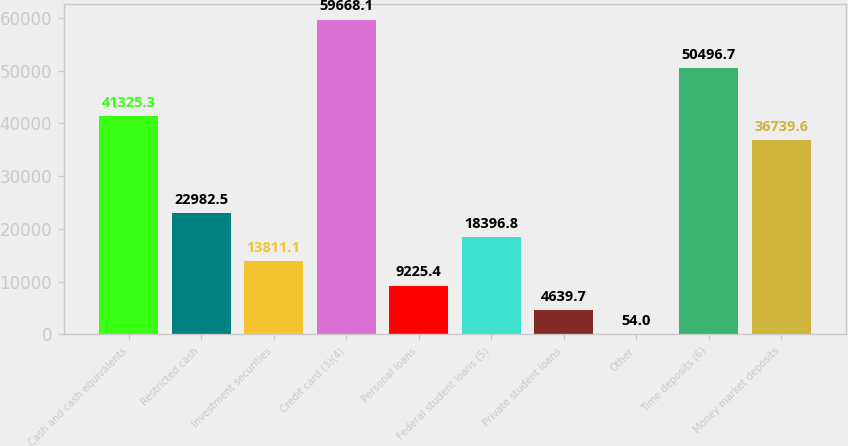Convert chart to OTSL. <chart><loc_0><loc_0><loc_500><loc_500><bar_chart><fcel>Cash and cash equivalents<fcel>Restricted cash<fcel>Investment securities<fcel>Credit card (3)(4)<fcel>Personal loans<fcel>Federal student loans (5)<fcel>Private student loans<fcel>Other<fcel>Time deposits (6)<fcel>Money market deposits<nl><fcel>41325.3<fcel>22982.5<fcel>13811.1<fcel>59668.1<fcel>9225.4<fcel>18396.8<fcel>4639.7<fcel>54<fcel>50496.7<fcel>36739.6<nl></chart> 